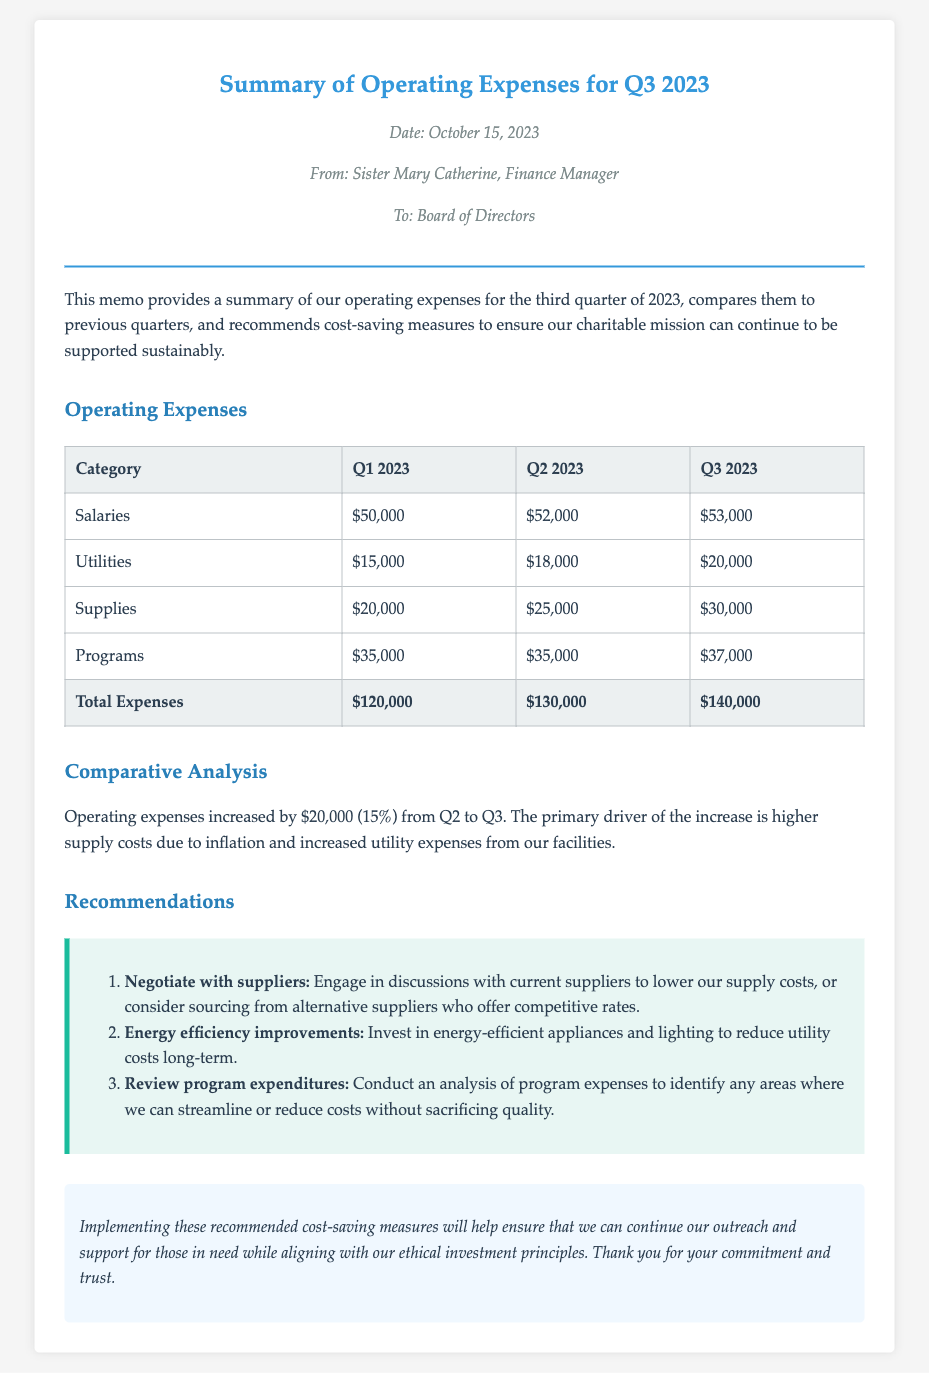What is the date of the memo? The date of the memo is mentioned in the meta section as October 15, 2023.
Answer: October 15, 2023 Who is the sender of the memo? The sender of the memo is identified as Sister Mary Catherine, the Finance Manager.
Answer: Sister Mary Catherine What were the total expenses for Q2 2023? The total expenses for Q2 2023 are provided in the table as $130,000.
Answer: $130,000 By how much did the operating expenses increase from Q2 to Q3? The increase in operating expenses from Q2 to Q3 is directly stated as $20,000.
Answer: $20,000 Which category had the highest expense in Q3 2023? The table shows that the Salaries category had the highest expense in Q3 2023 at $53,000.
Answer: Salaries What is one recommended measure to reduce utility costs? The memo suggests investing in energy-efficient appliances and lighting as a measure to reduce utility costs.
Answer: Energy efficiency improvements How much did Supplies expenses increase from Q2 to Q3? By comparing the figures for Supplies, the increase from Q2 to Q3 can be computed as $30,000 - $25,000 = $5,000.
Answer: $5,000 What is the primary driver of the increase in operating expenses? The primary driver of the increase in operating expenses is stated as higher supply costs due to inflation and increased utility expenses.
Answer: Higher supply costs What is the style used for the memo's body text? The body text style is set to a serif font, specifically 'Palatino Linotype'.
Answer: Palatino Linotype 